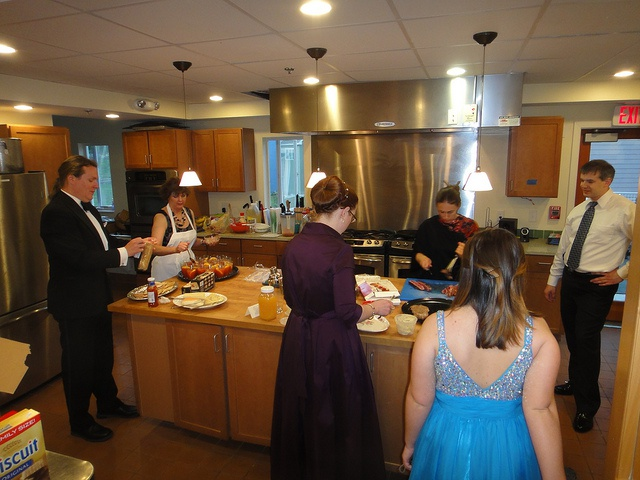Describe the objects in this image and their specific colors. I can see people in gray, tan, black, and teal tones, people in gray, black, and maroon tones, people in gray, black, brown, and maroon tones, people in gray, black, and tan tones, and refrigerator in gray, black, and olive tones in this image. 